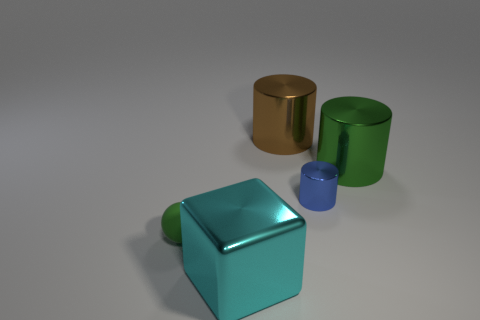Subtract all spheres. How many objects are left? 4 Add 3 small green objects. How many objects exist? 8 Subtract 0 blue cubes. How many objects are left? 5 Subtract all large green matte objects. Subtract all spheres. How many objects are left? 4 Add 5 large cubes. How many large cubes are left? 6 Add 4 tiny blue things. How many tiny blue things exist? 5 